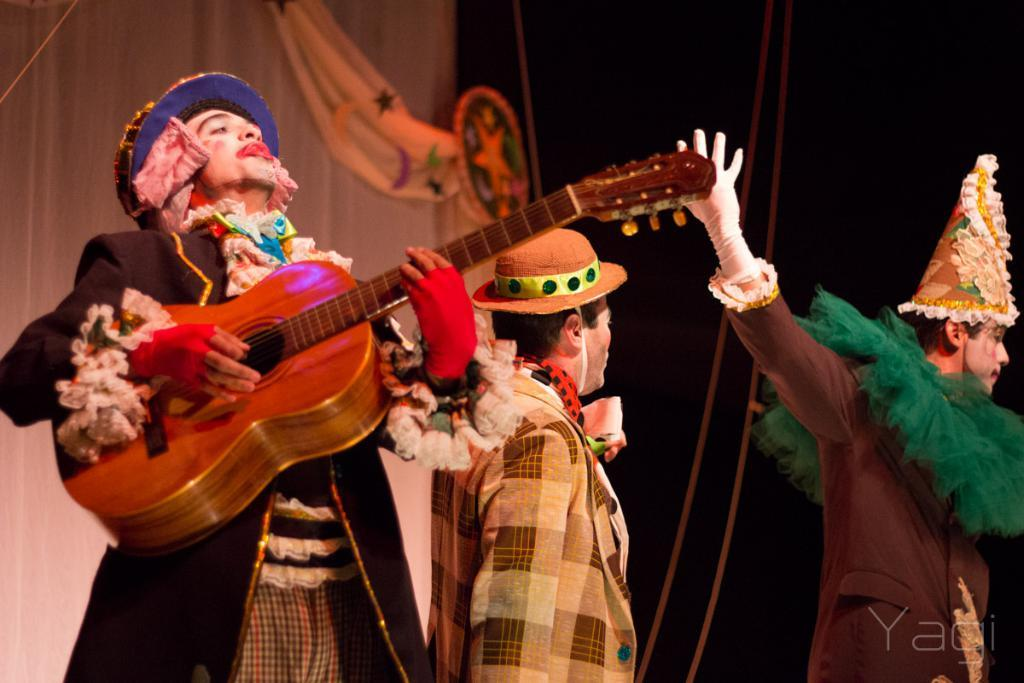How many people are in the image? There are three people in the image. What are the people wearing? All three people are wearing joker costumes. What is one of the people doing? One of the people is playing a guitar. What can be seen in the background of the image? There are two curtains in the background of the image. How many cushions are on the van in the image? There is no van present in the image, and therefore no cushions can be found on it. 